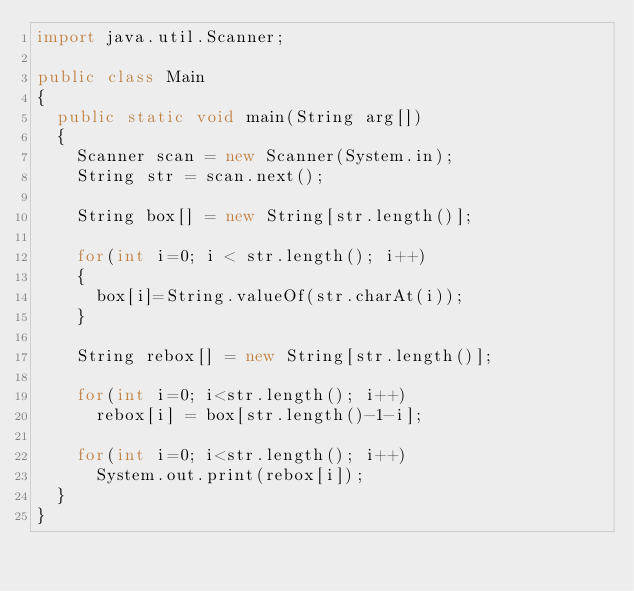<code> <loc_0><loc_0><loc_500><loc_500><_Java_>import java.util.Scanner;

public class Main
{
	public static void main(String arg[])
	{
		Scanner scan = new Scanner(System.in);
		String str = scan.next();

		String box[] = new String[str.length()];

		for(int i=0; i < str.length(); i++)
		{
			box[i]=String.valueOf(str.charAt(i));
		}

		String rebox[] = new String[str.length()];

		for(int i=0; i<str.length(); i++)
			rebox[i] = box[str.length()-1-i];

		for(int i=0; i<str.length(); i++)
			System.out.print(rebox[i]);
	}
}</code> 